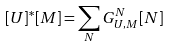<formula> <loc_0><loc_0><loc_500><loc_500>[ U ] ^ { * } [ M ] = \sum _ { N } G ^ { N } _ { U , M } [ N ]</formula> 